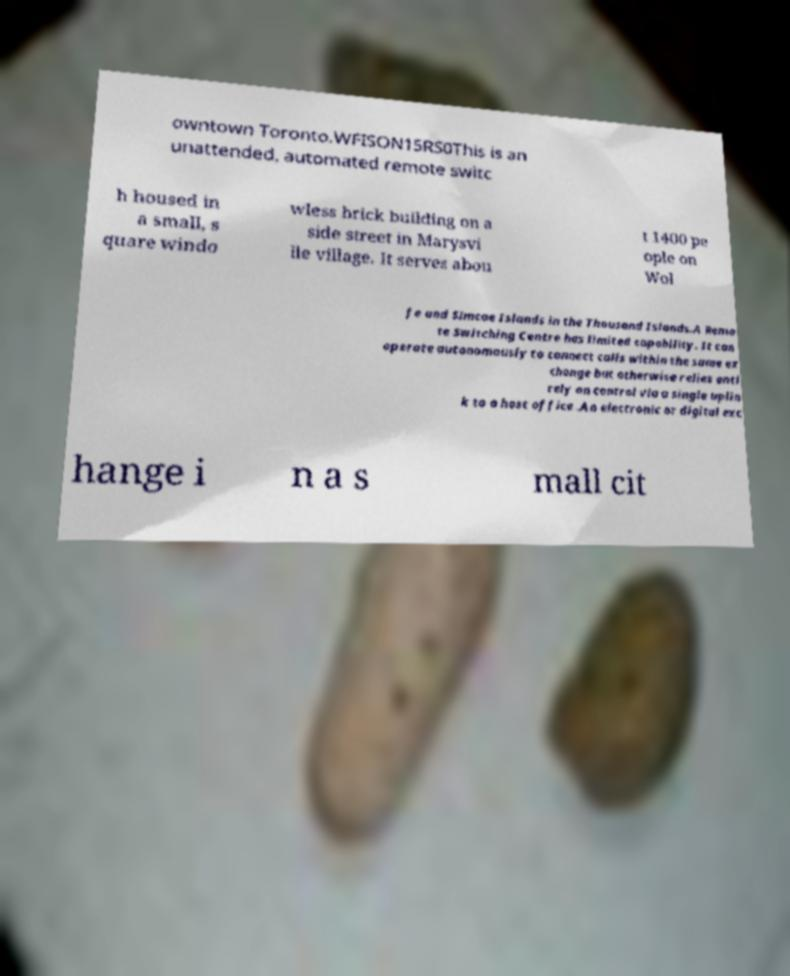Please identify and transcribe the text found in this image. owntown Toronto.WFISON15RS0This is an unattended, automated remote switc h housed in a small, s quare windo wless brick building on a side street in Marysvi lle village. It serves abou t 1400 pe ople on Wol fe and Simcoe Islands in the Thousand Islands.A Remo te Switching Centre has limited capability. It can operate autonomously to connect calls within the same ex change but otherwise relies enti rely on control via a single uplin k to a host office .An electronic or digital exc hange i n a s mall cit 